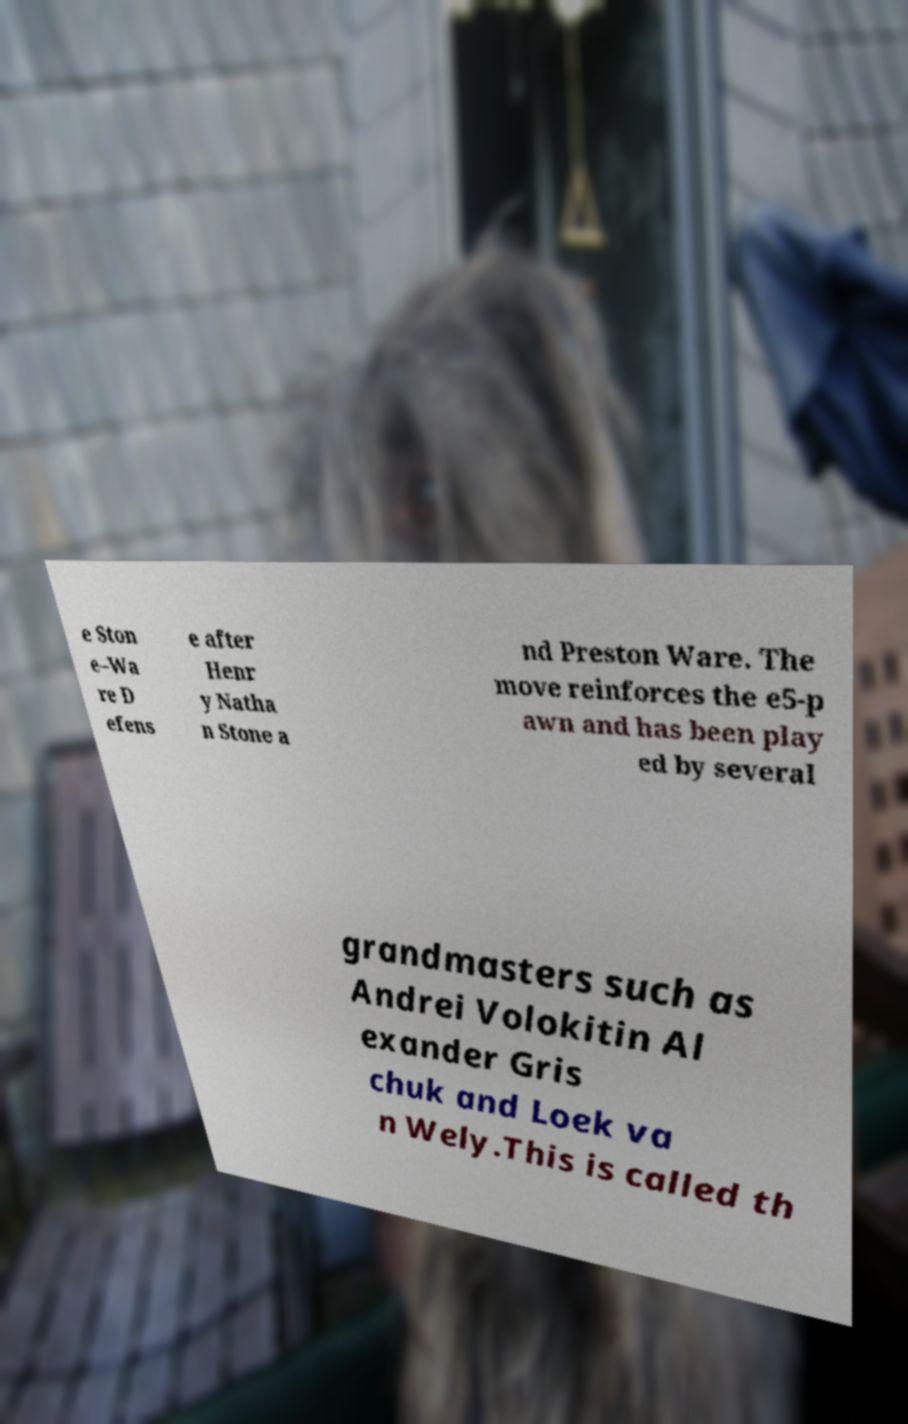Can you read and provide the text displayed in the image?This photo seems to have some interesting text. Can you extract and type it out for me? e Ston e–Wa re D efens e after Henr y Natha n Stone a nd Preston Ware. The move reinforces the e5-p awn and has been play ed by several grandmasters such as Andrei Volokitin Al exander Gris chuk and Loek va n Wely.This is called th 